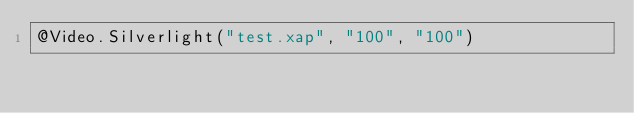<code> <loc_0><loc_0><loc_500><loc_500><_C#_>@Video.Silverlight("test.xap", "100", "100")</code> 